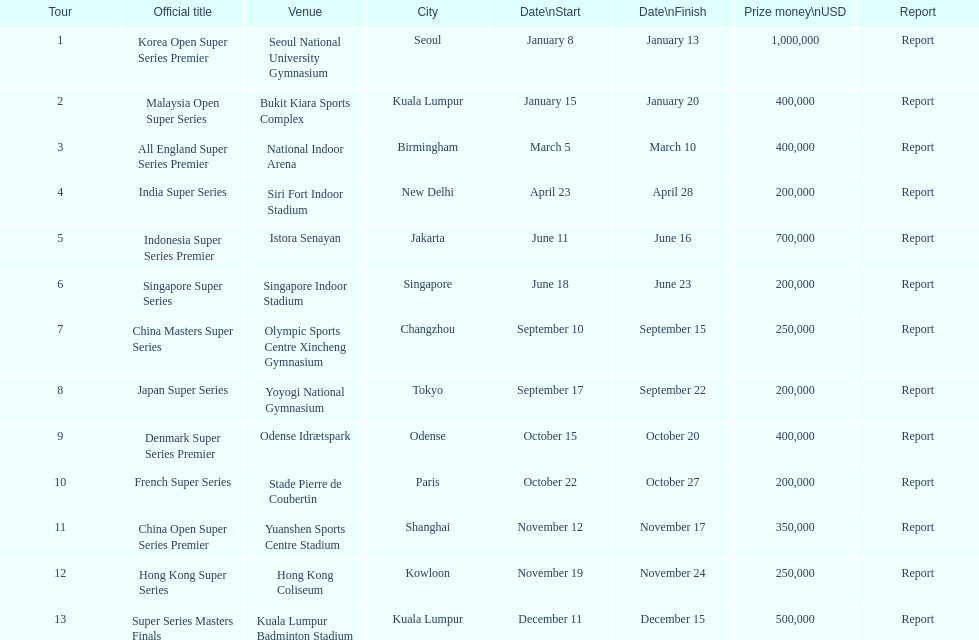Which was the sole tour that occurred in december? Super Series Masters Finals. 